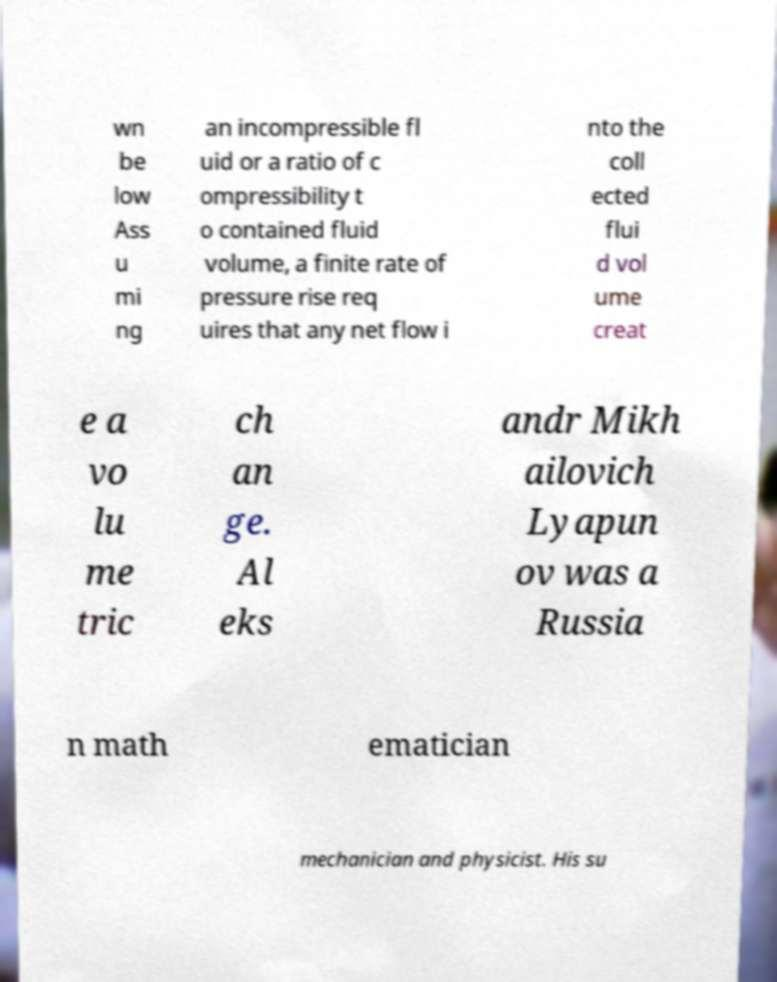Please identify and transcribe the text found in this image. wn be low Ass u mi ng an incompressible fl uid or a ratio of c ompressibility t o contained fluid volume, a finite rate of pressure rise req uires that any net flow i nto the coll ected flui d vol ume creat e a vo lu me tric ch an ge. Al eks andr Mikh ailovich Lyapun ov was a Russia n math ematician mechanician and physicist. His su 